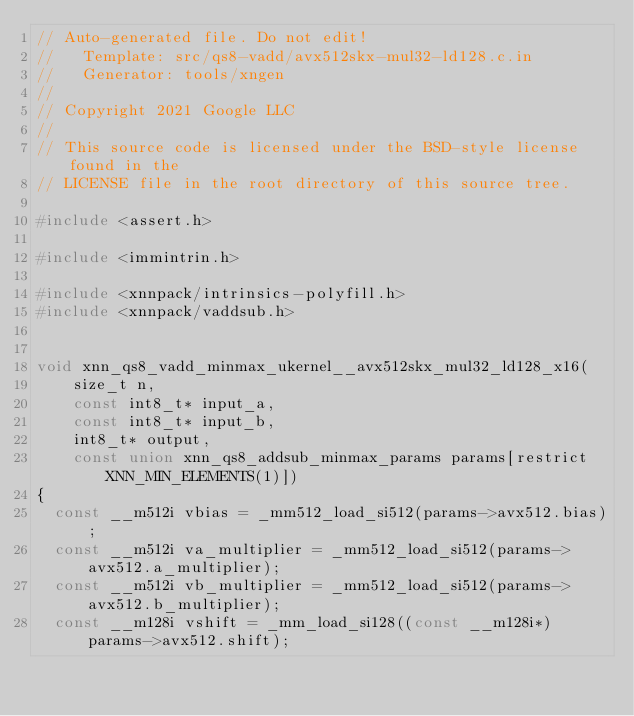<code> <loc_0><loc_0><loc_500><loc_500><_C_>// Auto-generated file. Do not edit!
//   Template: src/qs8-vadd/avx512skx-mul32-ld128.c.in
//   Generator: tools/xngen
//
// Copyright 2021 Google LLC
//
// This source code is licensed under the BSD-style license found in the
// LICENSE file in the root directory of this source tree.

#include <assert.h>

#include <immintrin.h>

#include <xnnpack/intrinsics-polyfill.h>
#include <xnnpack/vaddsub.h>


void xnn_qs8_vadd_minmax_ukernel__avx512skx_mul32_ld128_x16(
    size_t n,
    const int8_t* input_a,
    const int8_t* input_b,
    int8_t* output,
    const union xnn_qs8_addsub_minmax_params params[restrict XNN_MIN_ELEMENTS(1)])
{
  const __m512i vbias = _mm512_load_si512(params->avx512.bias);
  const __m512i va_multiplier = _mm512_load_si512(params->avx512.a_multiplier);
  const __m512i vb_multiplier = _mm512_load_si512(params->avx512.b_multiplier);
  const __m128i vshift = _mm_load_si128((const __m128i*) params->avx512.shift);</code> 